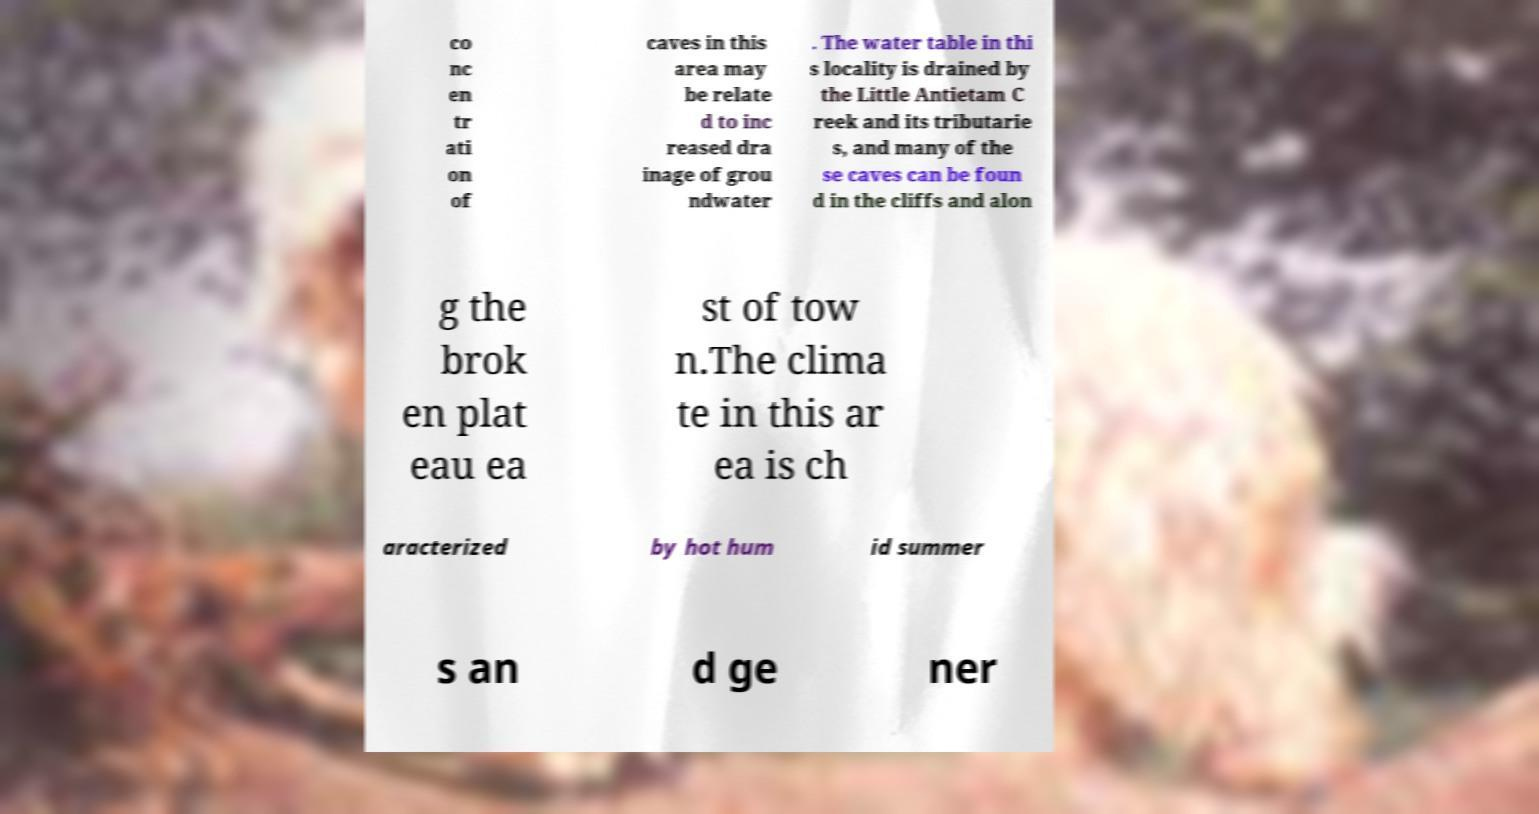I need the written content from this picture converted into text. Can you do that? co nc en tr ati on of caves in this area may be relate d to inc reased dra inage of grou ndwater . The water table in thi s locality is drained by the Little Antietam C reek and its tributarie s, and many of the se caves can be foun d in the cliffs and alon g the brok en plat eau ea st of tow n.The clima te in this ar ea is ch aracterized by hot hum id summer s an d ge ner 